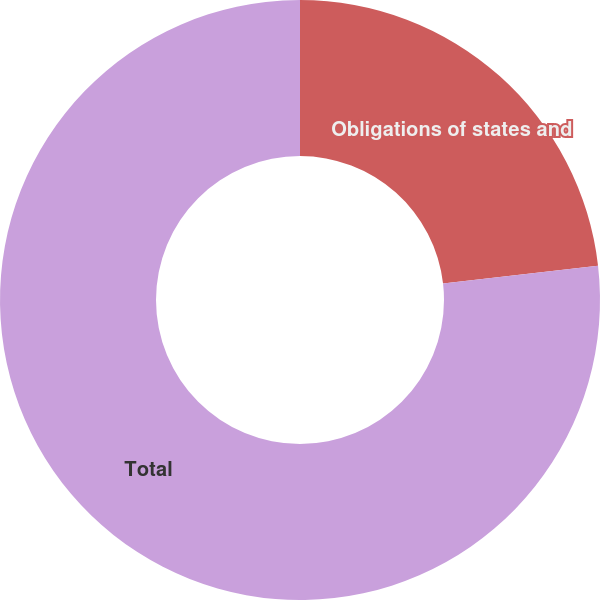Convert chart to OTSL. <chart><loc_0><loc_0><loc_500><loc_500><pie_chart><fcel>Obligations of states and<fcel>Total<nl><fcel>23.18%<fcel>76.82%<nl></chart> 